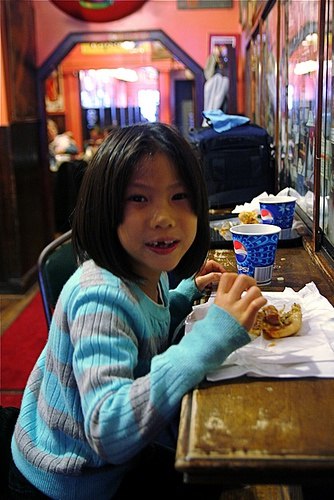Describe the objects in this image and their specific colors. I can see people in brown, black, maroon, lightblue, and teal tones, dining table in brown, black, maroon, and lightgray tones, cup in brown, navy, lightgray, blue, and darkblue tones, chair in brown, black, darkgray, gray, and navy tones, and hot dog in brown, olive, maroon, and tan tones in this image. 